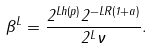Convert formula to latex. <formula><loc_0><loc_0><loc_500><loc_500>\beta ^ { L } = \frac { 2 ^ { L h ( p ) } 2 ^ { - L R ( 1 + a ) } } { 2 ^ { L } \nu } .</formula> 